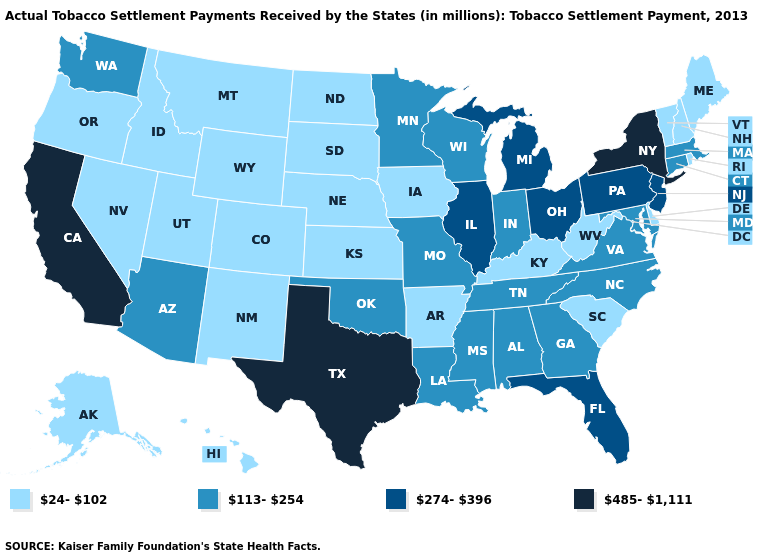What is the lowest value in states that border Indiana?
Keep it brief. 24-102. Does Texas have the highest value in the USA?
Quick response, please. Yes. Does South Carolina have the lowest value in the South?
Answer briefly. Yes. Among the states that border Maine , which have the lowest value?
Keep it brief. New Hampshire. What is the lowest value in states that border Arizona?
Keep it brief. 24-102. What is the lowest value in the MidWest?
Concise answer only. 24-102. Name the states that have a value in the range 274-396?
Keep it brief. Florida, Illinois, Michigan, New Jersey, Ohio, Pennsylvania. Does the map have missing data?
Give a very brief answer. No. Among the states that border California , which have the lowest value?
Quick response, please. Nevada, Oregon. Does the map have missing data?
Concise answer only. No. Does the map have missing data?
Quick response, please. No. Name the states that have a value in the range 24-102?
Write a very short answer. Alaska, Arkansas, Colorado, Delaware, Hawaii, Idaho, Iowa, Kansas, Kentucky, Maine, Montana, Nebraska, Nevada, New Hampshire, New Mexico, North Dakota, Oregon, Rhode Island, South Carolina, South Dakota, Utah, Vermont, West Virginia, Wyoming. Among the states that border Connecticut , does Massachusetts have the highest value?
Answer briefly. No. Does the first symbol in the legend represent the smallest category?
Write a very short answer. Yes. What is the lowest value in the South?
Quick response, please. 24-102. 